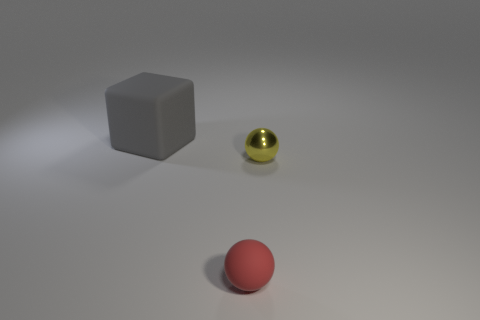How many other objects are the same shape as the big matte object?
Give a very brief answer. 0. There is a object that is both to the right of the gray object and on the left side of the small yellow sphere; what shape is it?
Your answer should be very brief. Sphere. What size is the rubber thing that is left of the red thing?
Provide a short and direct response. Large. Is the size of the red rubber thing the same as the gray thing?
Ensure brevity in your answer.  No. Is the number of small yellow objects that are right of the metallic object less than the number of small red objects on the left side of the red matte ball?
Your answer should be compact. No. There is a object that is behind the red sphere and left of the yellow thing; what size is it?
Give a very brief answer. Large. Are there any big matte blocks that are behind the large gray thing that is to the left of the yellow object that is to the right of the small red ball?
Provide a succinct answer. No. Are any purple balls visible?
Ensure brevity in your answer.  No. Is the number of yellow metal spheres in front of the tiny red object greater than the number of big rubber blocks that are behind the gray object?
Your answer should be compact. No. What size is the other red thing that is the same material as the large object?
Ensure brevity in your answer.  Small. 